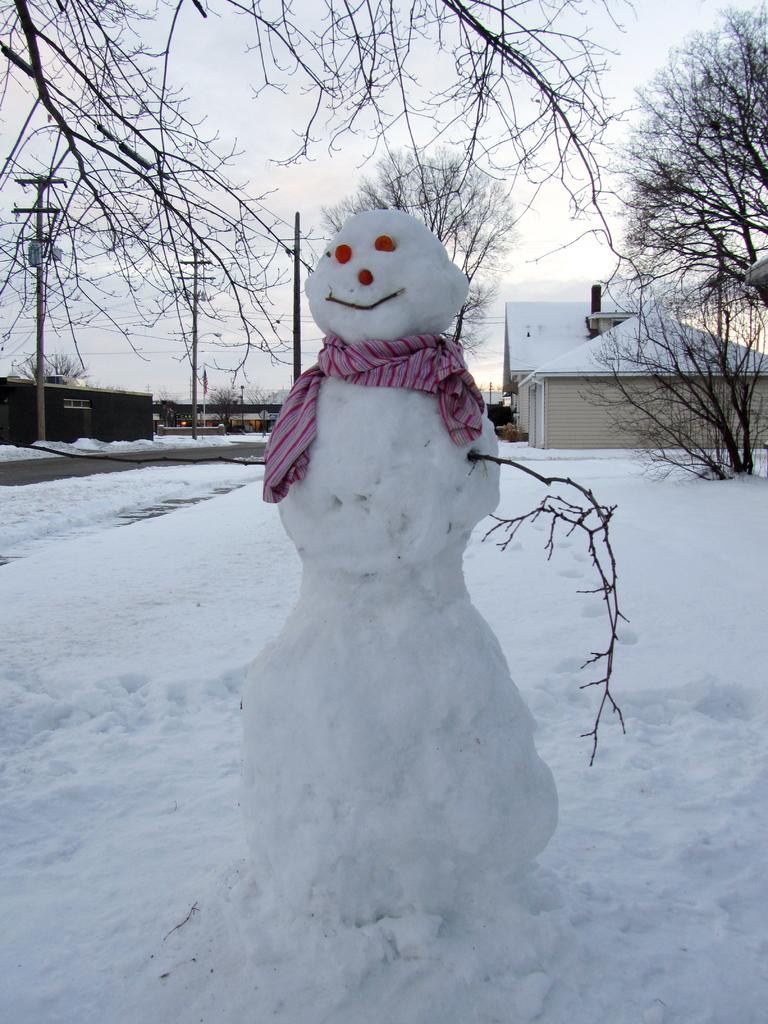What is the main object made of in the image? There is an object made with snow and cloth in the image. What type of natural elements can be seen in the image? There are trees in the image. What type of man-made structures are visible in the image? There are houses in the image. What other man-made objects can be seen in the image? There are poles and wires in the image. What is the condition of the ground in the image? The ground with snow is visible in the image. What is visible in the background of the image? The sky is visible in the image. Where is the playground located in the image? There is no playground present in the image. What type of hat is the snowman wearing in the image? There is no snowman or hat present in the image; it features an object made with snow and cloth. 